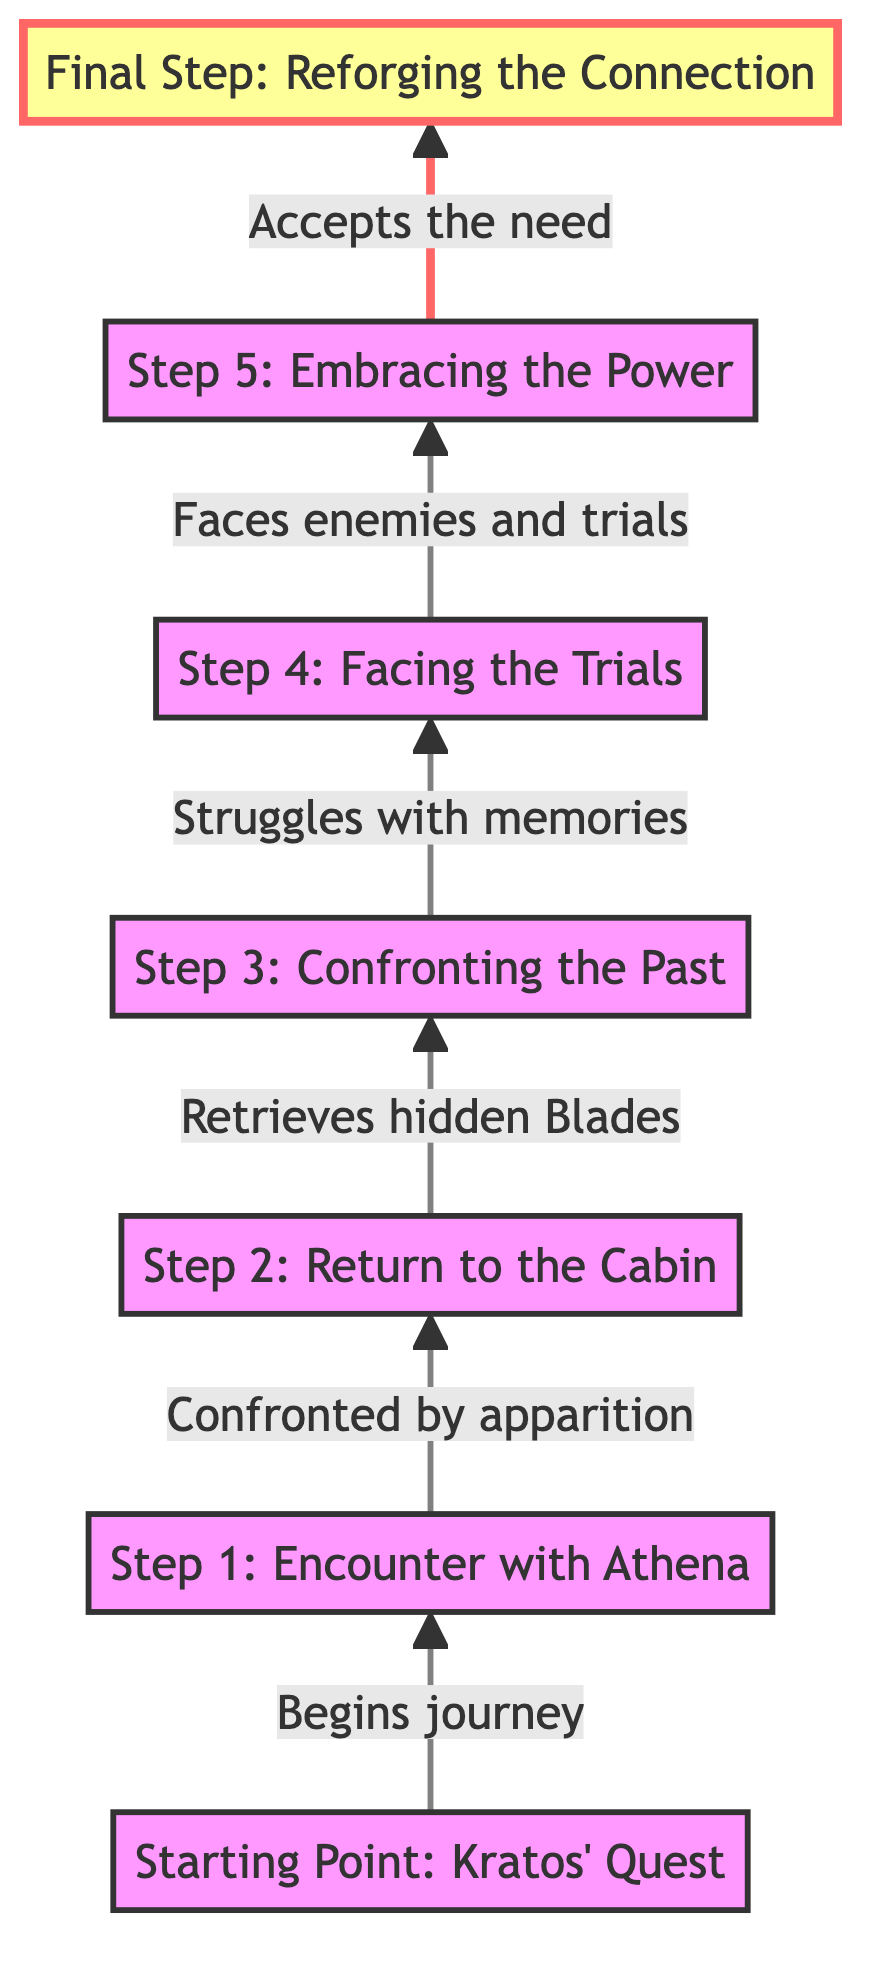What is the starting point of the flowchart? The starting point is specifically labeled as "Starting Point: Kratos' Quest" at the bottom of the flowchart. It initiates Kratos' journey to retrieve the Blades of Chaos.
Answer: Starting Point: Kratos' Quest How many steps are shown in the flowchart? By counting the nodes in the flowchart, there are a total of 6 steps leading to the final step, which are outlined in distinct titles.
Answer: 6 What is the final step in the process? The final step is labeled "Final Step: Reforging the Connection," indicating that it concludes the entire flow of actions to unlock the Blades of Chaos.
Answer: Final Step: Reforging the Connection Which step follows "Step 2: Return to the Cabin"? According to the flowchart, after "Step 2: Return to the Cabin," the next step is "Step 3: Confronting the Past," establishing the progression in Kratos' journey.
Answer: Step 3: Confronting the Past What does Kratos struggle with in "Step 3: Confronting the Past"? In this step, it states that Kratos struggles with memories of his past deeds, indicating the emotional challenge he faces while retrieving the Blades.
Answer: Memories of his past deeds What is the relationship between "Step 4: Facing the Trials" and "Step 5: Embracing the Power"? "Step 4: Facing the Trials" leads to "Step 5: Embracing the Power," depicting a progression where Kratos must first confront trials before he can fully embrace the power of the Blades.
Answer: Leads to What does Kratos need to accept in "Step 5"? In "Step 5: Embracing the Power," it specifies that Kratos needs to accept the need for the Blades of Chaos, which implies an important emotional decision in his journey.
Answer: Accept the need for the Blades of Chaos Which step involves confronting an apparition? The step where Kratos encounters an apparition is "Step 1: Encounter with Athena," where Athena reminds him of his past regarding the Blades.
Answer: Step 1: Encounter with Athena What progression does the flowchart illustrate about Kratos' emotional journey? The flowchart outlines an emotional journey where Kratos first confronts his past, faces trials, and ultimately embraces his history with the Blades to prepare himself for future challenges.
Answer: Emotional journey from confronting the past to embracing his history 